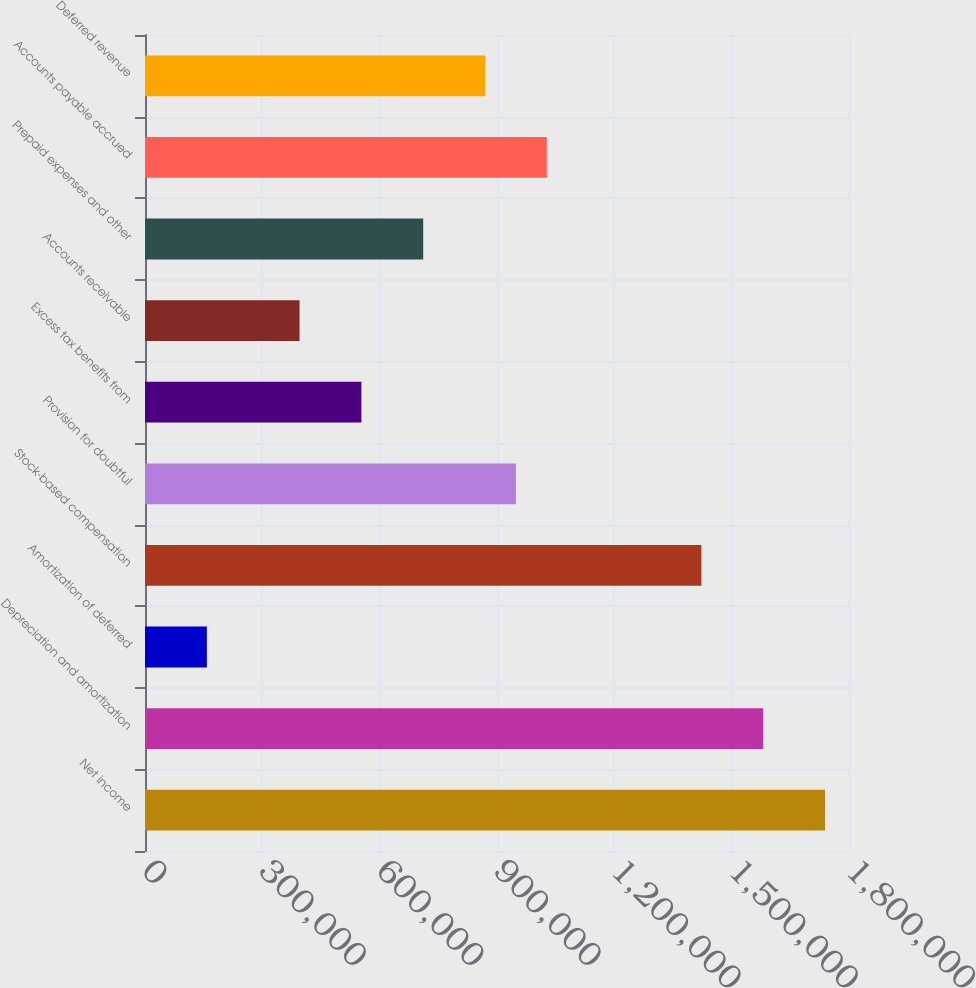<chart> <loc_0><loc_0><loc_500><loc_500><bar_chart><fcel>Net income<fcel>Depreciation and amortization<fcel>Amortization of deferred<fcel>Stock-based compensation<fcel>Provision for doubtful<fcel>Excess tax benefits from<fcel>Accounts receivable<fcel>Prepaid expenses and other<fcel>Accounts payable accrued<fcel>Deferred revenue<nl><fcel>1.73866e+06<fcel>1.58061e+06<fcel>158145<fcel>1.42256e+06<fcel>948403<fcel>553274<fcel>395222<fcel>711325<fcel>1.02743e+06<fcel>869377<nl></chart> 